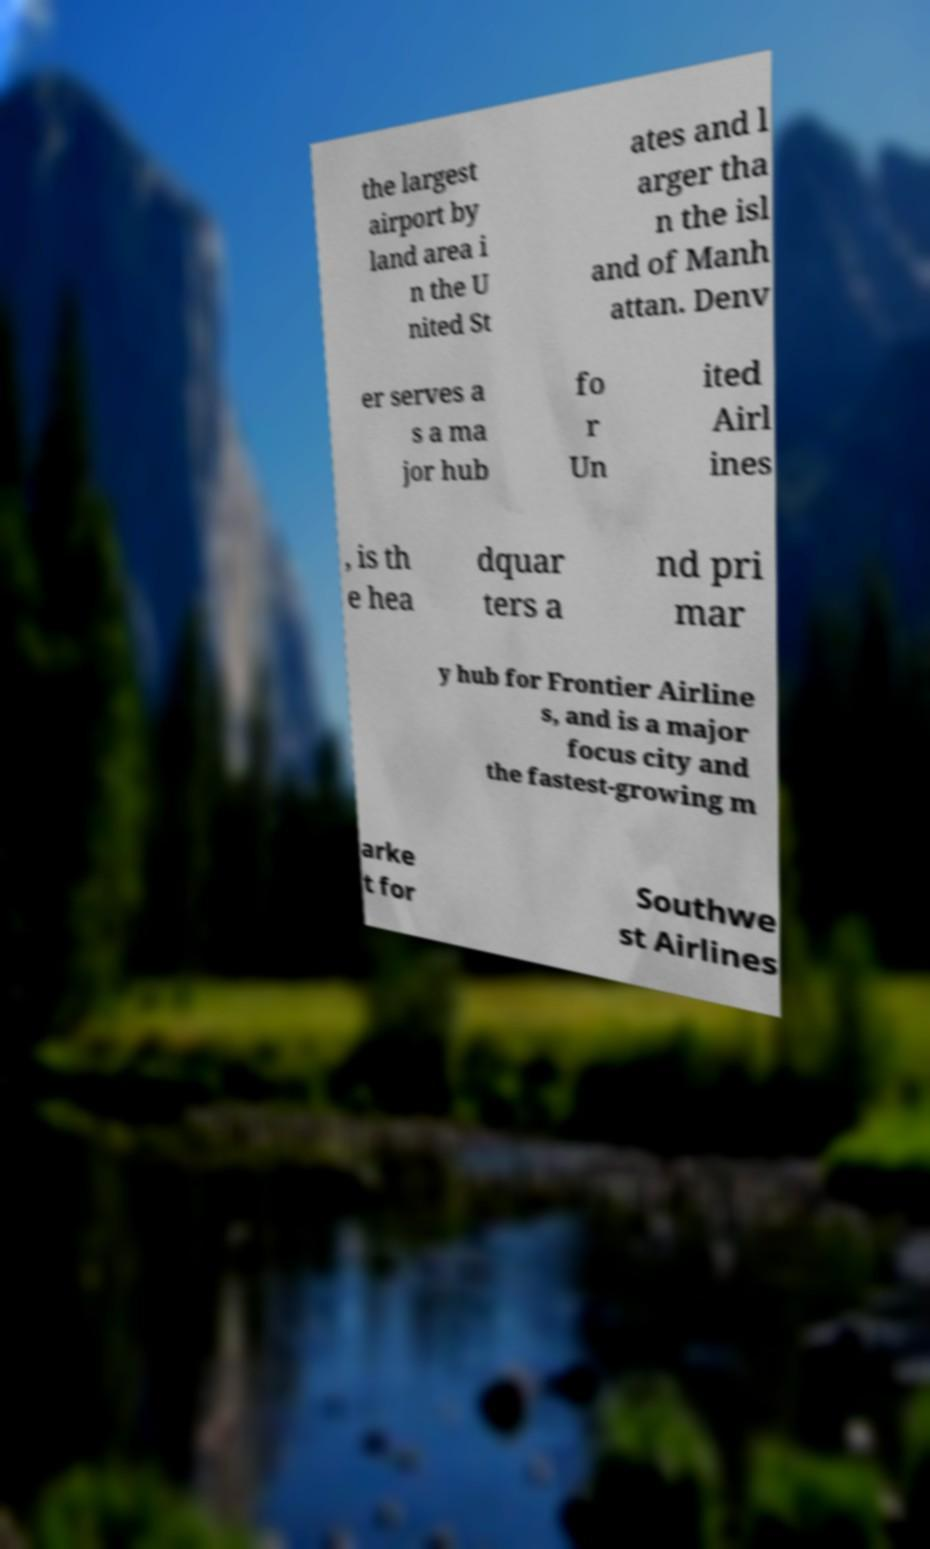I need the written content from this picture converted into text. Can you do that? the largest airport by land area i n the U nited St ates and l arger tha n the isl and of Manh attan. Denv er serves a s a ma jor hub fo r Un ited Airl ines , is th e hea dquar ters a nd pri mar y hub for Frontier Airline s, and is a major focus city and the fastest-growing m arke t for Southwe st Airlines 